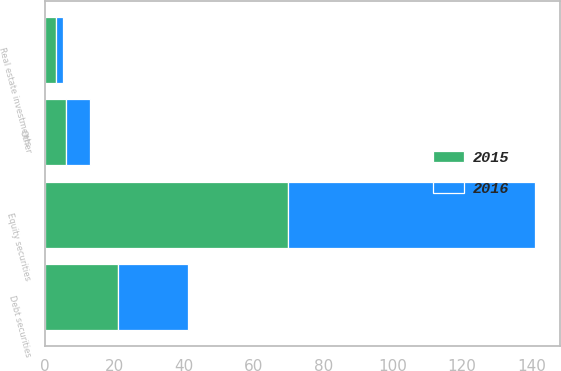<chart> <loc_0><loc_0><loc_500><loc_500><stacked_bar_chart><ecel><fcel>Equity securities<fcel>Debt securities<fcel>Real estate investments<fcel>Other<nl><fcel>2016<fcel>71<fcel>20<fcel>2<fcel>7<nl><fcel>2015<fcel>70<fcel>21<fcel>3<fcel>6<nl></chart> 